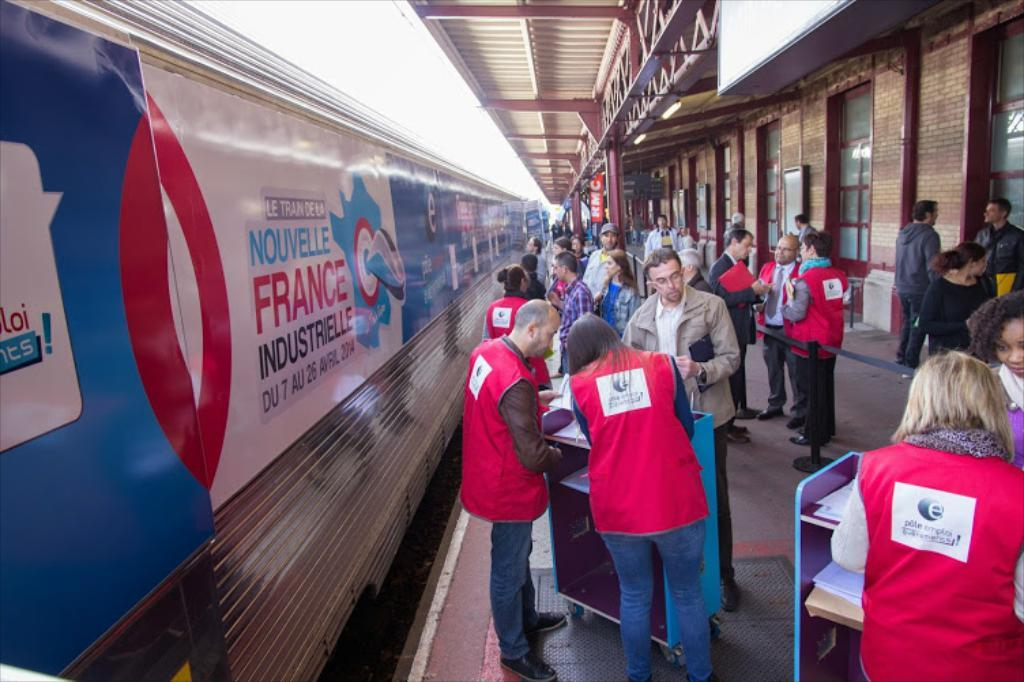What is the main subject of the image? The main subject of the image is a group of people standing near a fountain. Where is the fountain located? The fountain is in the middle of a park. What else can be seen in the background of the image? There are trees and a building visible in the background. How many apples are being represented by the fountain in the image? There are no apples present in the image, and the fountain is not representing any apples. 